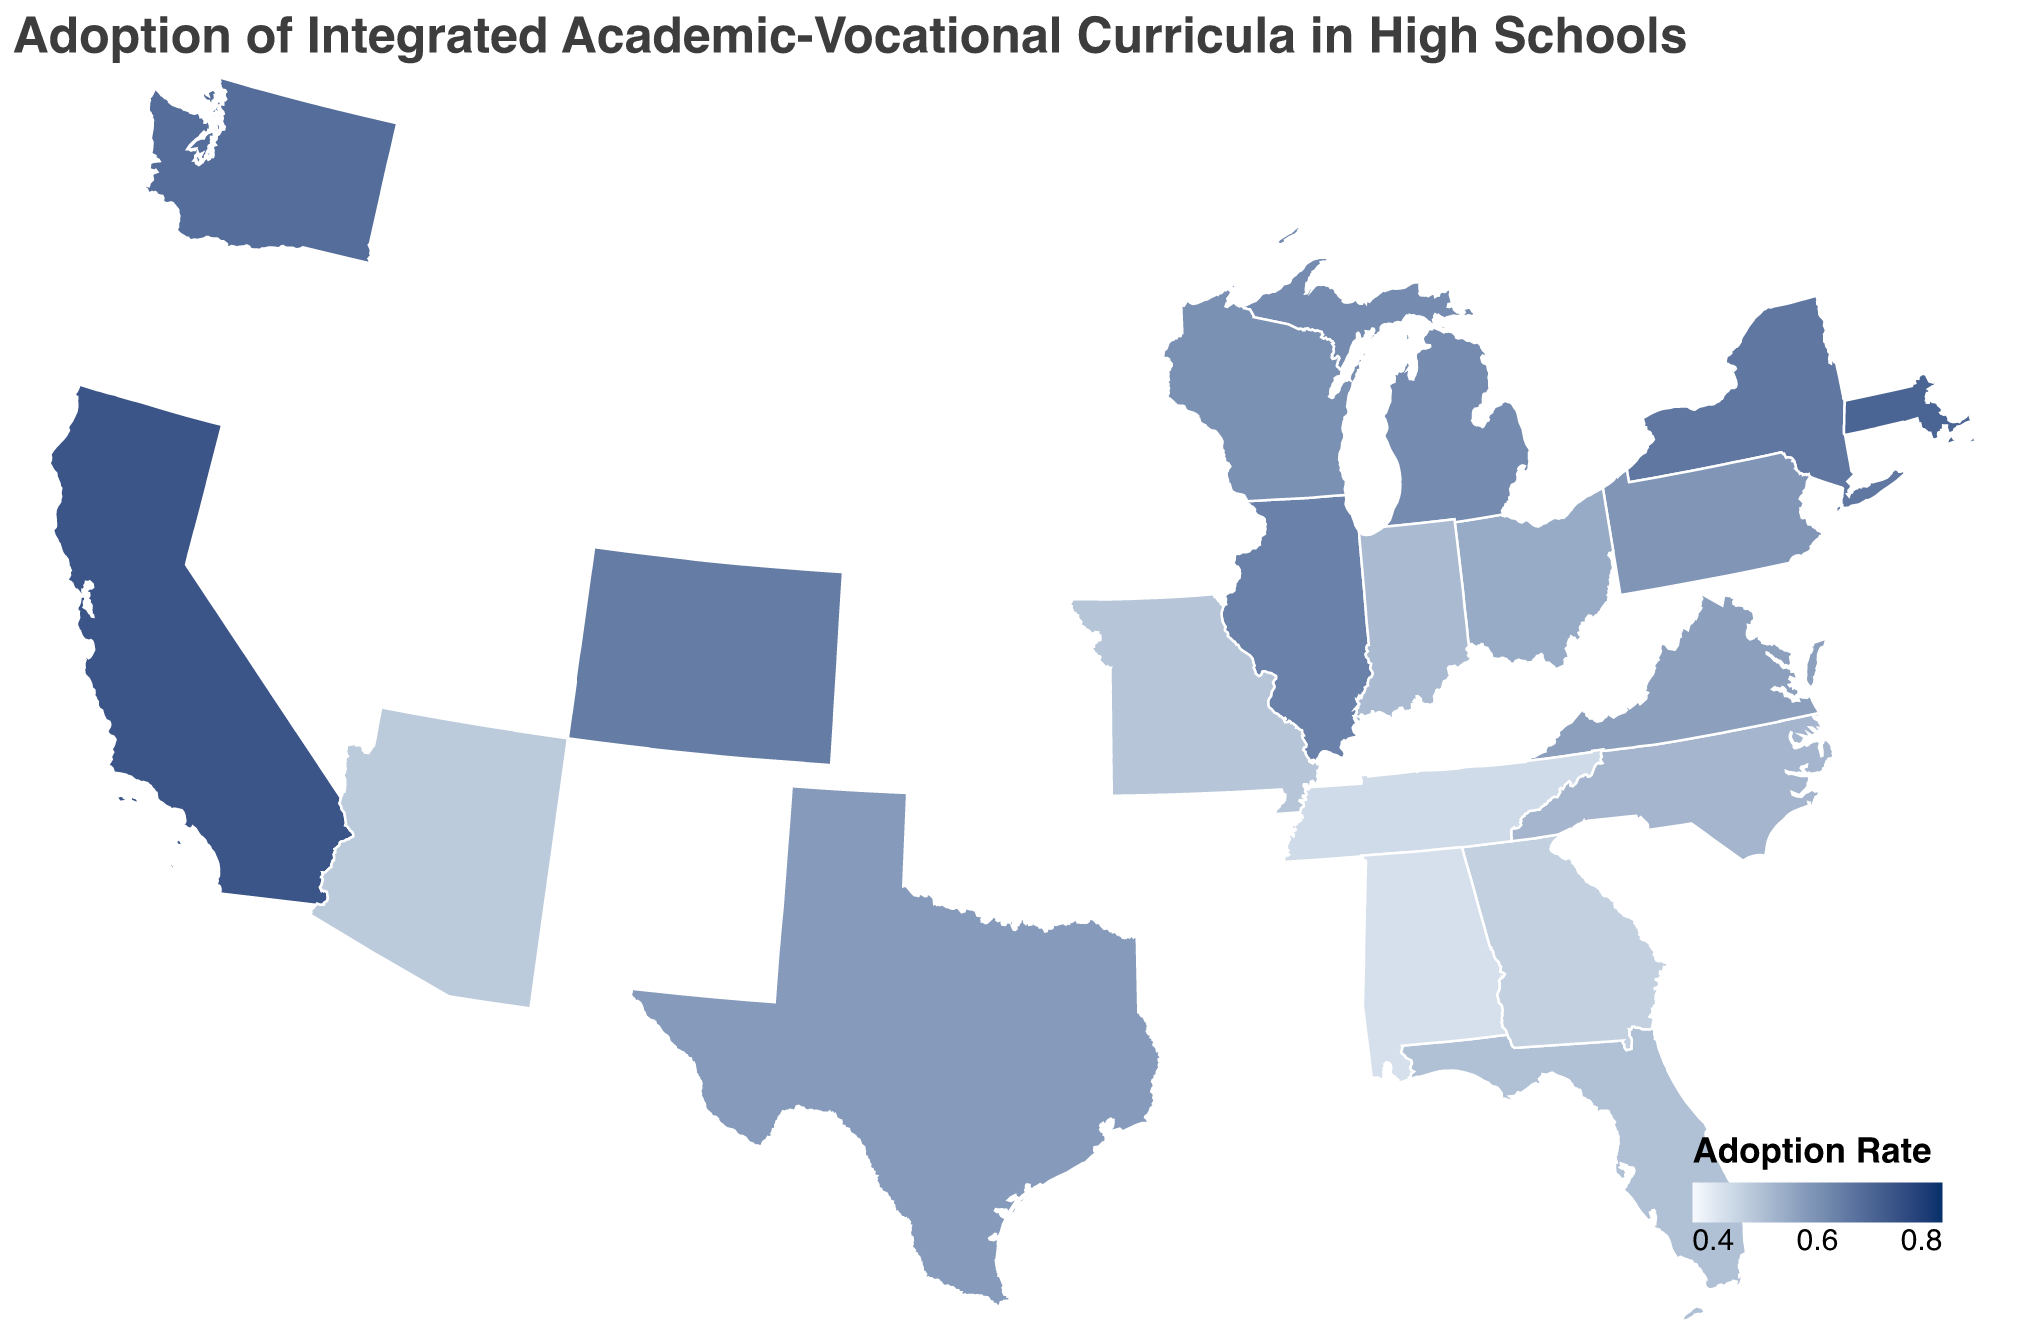What's the highest adoption rate displayed on the map? Identify the color that represents the highest adoption rate, which in this case corresponds to the darkest shade of blue, and then refer to the tooltip which shows the rate.
Answer: 0.72 Which state has the lowest adoption rate of integrated curricula? Find the state with the lightest shade of blue, refer to the tooltip to verify the exact adoption rate and state.
Answer: Alabama What is the adoption rate in California? Hover over California on the map to check its tooltip, which shows the adoption rate for the state.
Answer: 0.72 Compare the adoption rates of Texas and New York. Which state has a higher adoption rate? Check the adoption rates for both Texas and New York displayed on the map's tooltips and compare them.
Answer: New York Calculate the average adoption rate of the states displayed on the map. Add up all the adoption rates and then divide by the number of states (20). The rates summed are: 0.72 + 0.58 + 0.65 + 0.51 + 0.63 + 0.59 + 0.55 + 0.61 + 0.48 + 0.53 + 0.57 + 0.69 + 0.67 + 0.49 + 0.46 + 0.52 + 0.50 + 0.60 + 0.64 + 0.45, giving a total of 11.72. Divide by 20 to find the average.
Answer: 0.586 Are there more states with an adoption rate above 0.60 or below 0.60? Count the number of states above and below an adoption rate of 0.60 by inspecting their color shades and tooltips.
Answer: Below 0.60 Which region (West Coast, East Coast, Midwest, South) seems to have the highest overall adoption rates? Evaluate clusters of states in the West Coast, East Coast, Midwest, and South, using the corresponding color shades on the map.
Answer: West Coast Which state has an adoption rate closest to the overall average? Calculate the overall average adoption rate (0.586), then find the state whose adoption rate is closest to this average by comparing the nearby rates.
Answer: Ohio What is the color range used to indicate adoption rates on the map? Look at the gradient in the legend to identify the colors at the extremes that indicate the range of adoption rates.
Answer: Light blue to dark blue How many states have an adoption rate of 0.60 or higher? Count the states with a color representing an adoption rate of 0.60 or higher by checking their tooltips.
Answer: 7 